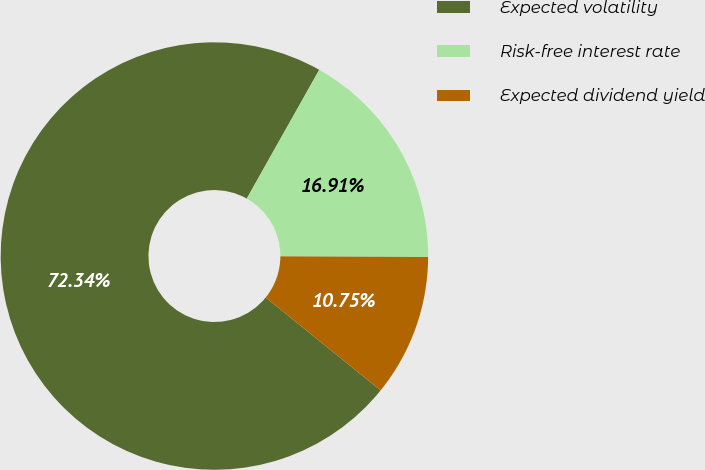Convert chart to OTSL. <chart><loc_0><loc_0><loc_500><loc_500><pie_chart><fcel>Expected volatility<fcel>Risk-free interest rate<fcel>Expected dividend yield<nl><fcel>72.34%<fcel>16.91%<fcel>10.75%<nl></chart> 